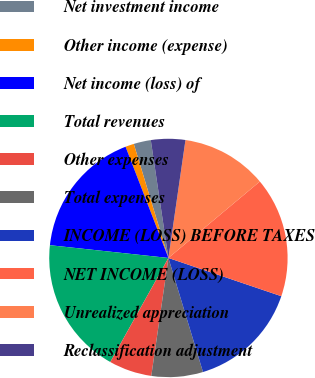Convert chart to OTSL. <chart><loc_0><loc_0><loc_500><loc_500><pie_chart><fcel>Net investment income<fcel>Other income (expense)<fcel>Net income (loss) of<fcel>Total revenues<fcel>Other expenses<fcel>Total expenses<fcel>INCOME (LOSS) BEFORE TAXES<fcel>NET INCOME (LOSS)<fcel>Unrealized appreciation<fcel>Reclassification adjustment<nl><fcel>2.33%<fcel>1.16%<fcel>17.44%<fcel>18.6%<fcel>5.81%<fcel>6.98%<fcel>15.12%<fcel>16.28%<fcel>11.63%<fcel>4.65%<nl></chart> 